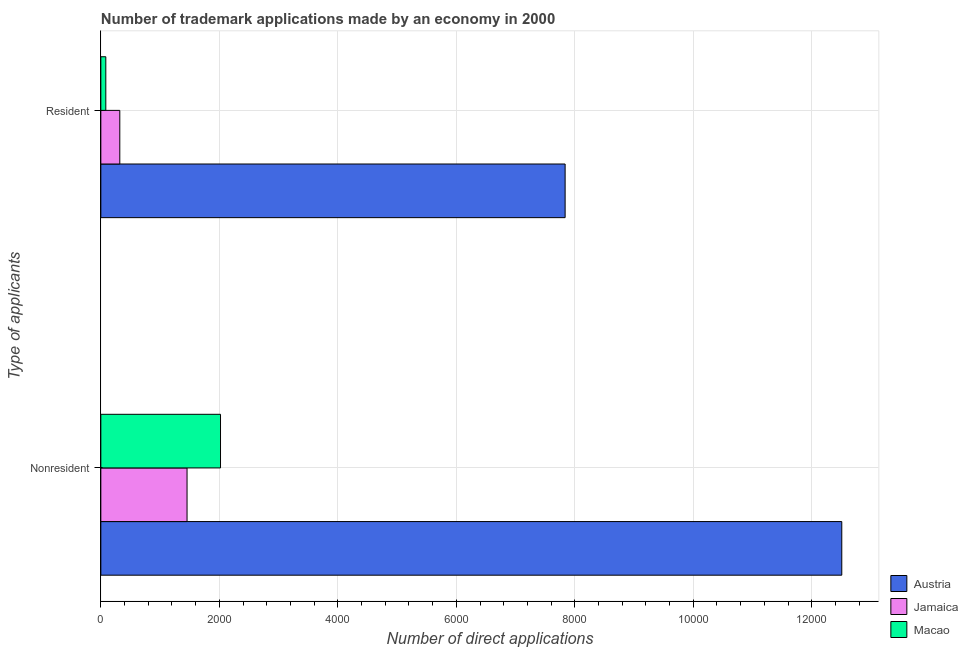Are the number of bars on each tick of the Y-axis equal?
Provide a succinct answer. Yes. How many bars are there on the 1st tick from the bottom?
Give a very brief answer. 3. What is the label of the 2nd group of bars from the top?
Ensure brevity in your answer.  Nonresident. What is the number of trademark applications made by residents in Austria?
Provide a short and direct response. 7837. Across all countries, what is the maximum number of trademark applications made by residents?
Your answer should be very brief. 7837. Across all countries, what is the minimum number of trademark applications made by residents?
Offer a very short reply. 84. In which country was the number of trademark applications made by non residents minimum?
Provide a succinct answer. Jamaica. What is the total number of trademark applications made by non residents in the graph?
Provide a succinct answer. 1.60e+04. What is the difference between the number of trademark applications made by non residents in Macao and that in Austria?
Keep it short and to the point. -1.05e+04. What is the difference between the number of trademark applications made by non residents in Austria and the number of trademark applications made by residents in Jamaica?
Provide a short and direct response. 1.22e+04. What is the average number of trademark applications made by non residents per country?
Keep it short and to the point. 5327.33. What is the difference between the number of trademark applications made by non residents and number of trademark applications made by residents in Austria?
Give a very brief answer. 4670. What is the ratio of the number of trademark applications made by non residents in Jamaica to that in Macao?
Make the answer very short. 0.72. Is the number of trademark applications made by non residents in Austria less than that in Jamaica?
Your answer should be compact. No. In how many countries, is the number of trademark applications made by residents greater than the average number of trademark applications made by residents taken over all countries?
Your answer should be very brief. 1. What does the 2nd bar from the top in Resident represents?
Keep it short and to the point. Jamaica. What does the 3rd bar from the bottom in Resident represents?
Make the answer very short. Macao. How many countries are there in the graph?
Your answer should be very brief. 3. Does the graph contain grids?
Provide a short and direct response. Yes. How many legend labels are there?
Make the answer very short. 3. How are the legend labels stacked?
Provide a succinct answer. Vertical. What is the title of the graph?
Make the answer very short. Number of trademark applications made by an economy in 2000. Does "Serbia" appear as one of the legend labels in the graph?
Offer a very short reply. No. What is the label or title of the X-axis?
Your response must be concise. Number of direct applications. What is the label or title of the Y-axis?
Ensure brevity in your answer.  Type of applicants. What is the Number of direct applications in Austria in Nonresident?
Your answer should be very brief. 1.25e+04. What is the Number of direct applications of Jamaica in Nonresident?
Keep it short and to the point. 1455. What is the Number of direct applications in Macao in Nonresident?
Your response must be concise. 2020. What is the Number of direct applications in Austria in Resident?
Give a very brief answer. 7837. What is the Number of direct applications of Jamaica in Resident?
Give a very brief answer. 320. Across all Type of applicants, what is the maximum Number of direct applications of Austria?
Provide a succinct answer. 1.25e+04. Across all Type of applicants, what is the maximum Number of direct applications of Jamaica?
Provide a short and direct response. 1455. Across all Type of applicants, what is the maximum Number of direct applications in Macao?
Provide a short and direct response. 2020. Across all Type of applicants, what is the minimum Number of direct applications in Austria?
Your response must be concise. 7837. Across all Type of applicants, what is the minimum Number of direct applications of Jamaica?
Ensure brevity in your answer.  320. What is the total Number of direct applications in Austria in the graph?
Offer a terse response. 2.03e+04. What is the total Number of direct applications of Jamaica in the graph?
Your answer should be compact. 1775. What is the total Number of direct applications in Macao in the graph?
Your response must be concise. 2104. What is the difference between the Number of direct applications in Austria in Nonresident and that in Resident?
Offer a very short reply. 4670. What is the difference between the Number of direct applications of Jamaica in Nonresident and that in Resident?
Give a very brief answer. 1135. What is the difference between the Number of direct applications in Macao in Nonresident and that in Resident?
Your answer should be very brief. 1936. What is the difference between the Number of direct applications in Austria in Nonresident and the Number of direct applications in Jamaica in Resident?
Ensure brevity in your answer.  1.22e+04. What is the difference between the Number of direct applications of Austria in Nonresident and the Number of direct applications of Macao in Resident?
Give a very brief answer. 1.24e+04. What is the difference between the Number of direct applications in Jamaica in Nonresident and the Number of direct applications in Macao in Resident?
Provide a succinct answer. 1371. What is the average Number of direct applications of Austria per Type of applicants?
Your response must be concise. 1.02e+04. What is the average Number of direct applications in Jamaica per Type of applicants?
Provide a succinct answer. 887.5. What is the average Number of direct applications in Macao per Type of applicants?
Ensure brevity in your answer.  1052. What is the difference between the Number of direct applications of Austria and Number of direct applications of Jamaica in Nonresident?
Provide a succinct answer. 1.11e+04. What is the difference between the Number of direct applications of Austria and Number of direct applications of Macao in Nonresident?
Provide a succinct answer. 1.05e+04. What is the difference between the Number of direct applications of Jamaica and Number of direct applications of Macao in Nonresident?
Offer a very short reply. -565. What is the difference between the Number of direct applications in Austria and Number of direct applications in Jamaica in Resident?
Your answer should be compact. 7517. What is the difference between the Number of direct applications of Austria and Number of direct applications of Macao in Resident?
Provide a short and direct response. 7753. What is the difference between the Number of direct applications in Jamaica and Number of direct applications in Macao in Resident?
Offer a very short reply. 236. What is the ratio of the Number of direct applications in Austria in Nonresident to that in Resident?
Provide a succinct answer. 1.6. What is the ratio of the Number of direct applications of Jamaica in Nonresident to that in Resident?
Your response must be concise. 4.55. What is the ratio of the Number of direct applications of Macao in Nonresident to that in Resident?
Your answer should be compact. 24.05. What is the difference between the highest and the second highest Number of direct applications in Austria?
Provide a short and direct response. 4670. What is the difference between the highest and the second highest Number of direct applications of Jamaica?
Provide a short and direct response. 1135. What is the difference between the highest and the second highest Number of direct applications in Macao?
Your answer should be compact. 1936. What is the difference between the highest and the lowest Number of direct applications of Austria?
Your answer should be compact. 4670. What is the difference between the highest and the lowest Number of direct applications in Jamaica?
Keep it short and to the point. 1135. What is the difference between the highest and the lowest Number of direct applications in Macao?
Your answer should be compact. 1936. 